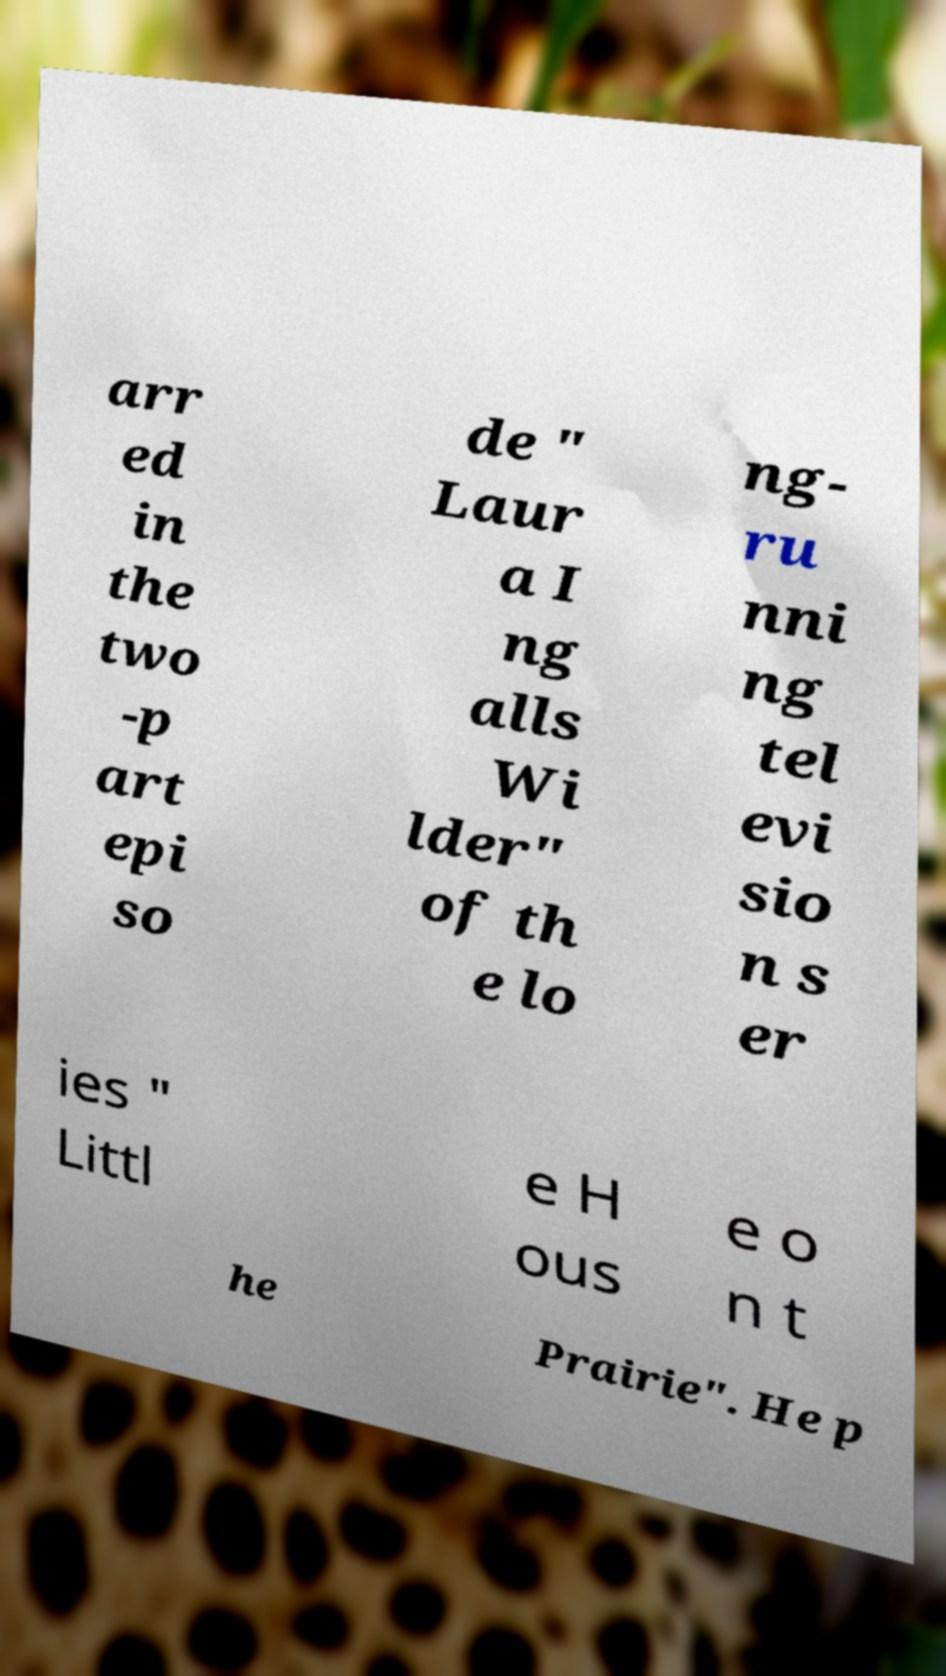For documentation purposes, I need the text within this image transcribed. Could you provide that? arr ed in the two -p art epi so de " Laur a I ng alls Wi lder" of th e lo ng- ru nni ng tel evi sio n s er ies " Littl e H ous e o n t he Prairie". He p 